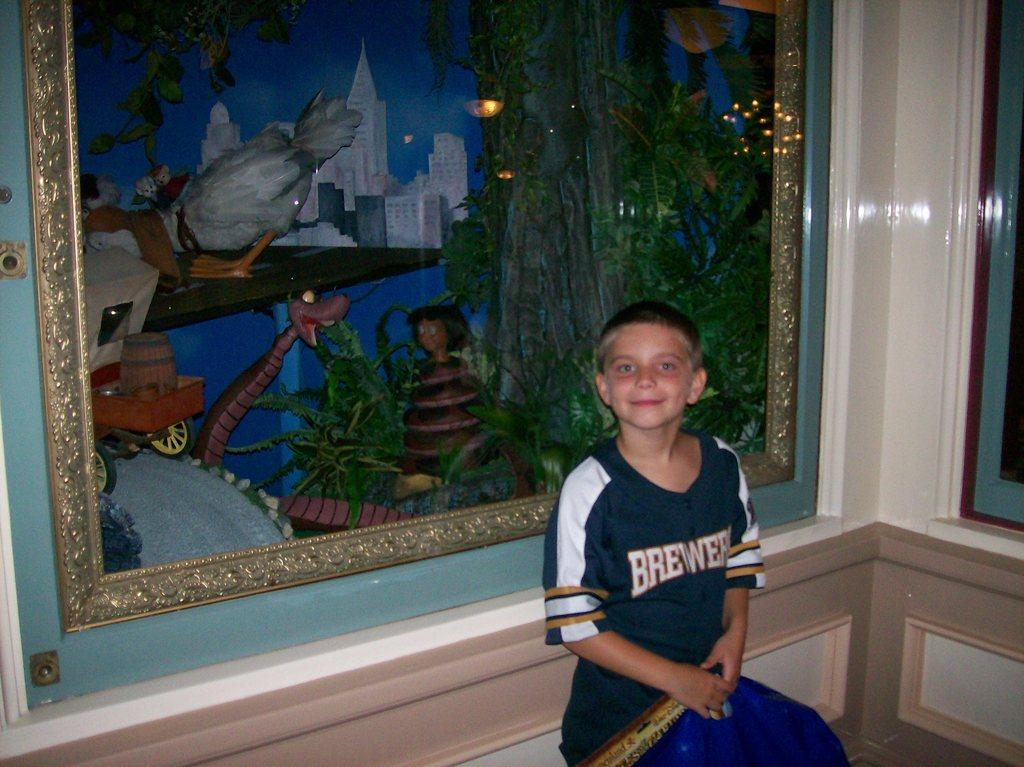Provide a one-sentence caption for the provided image. A small child sitting next to a framed painting while wearing a brewers shirt. 